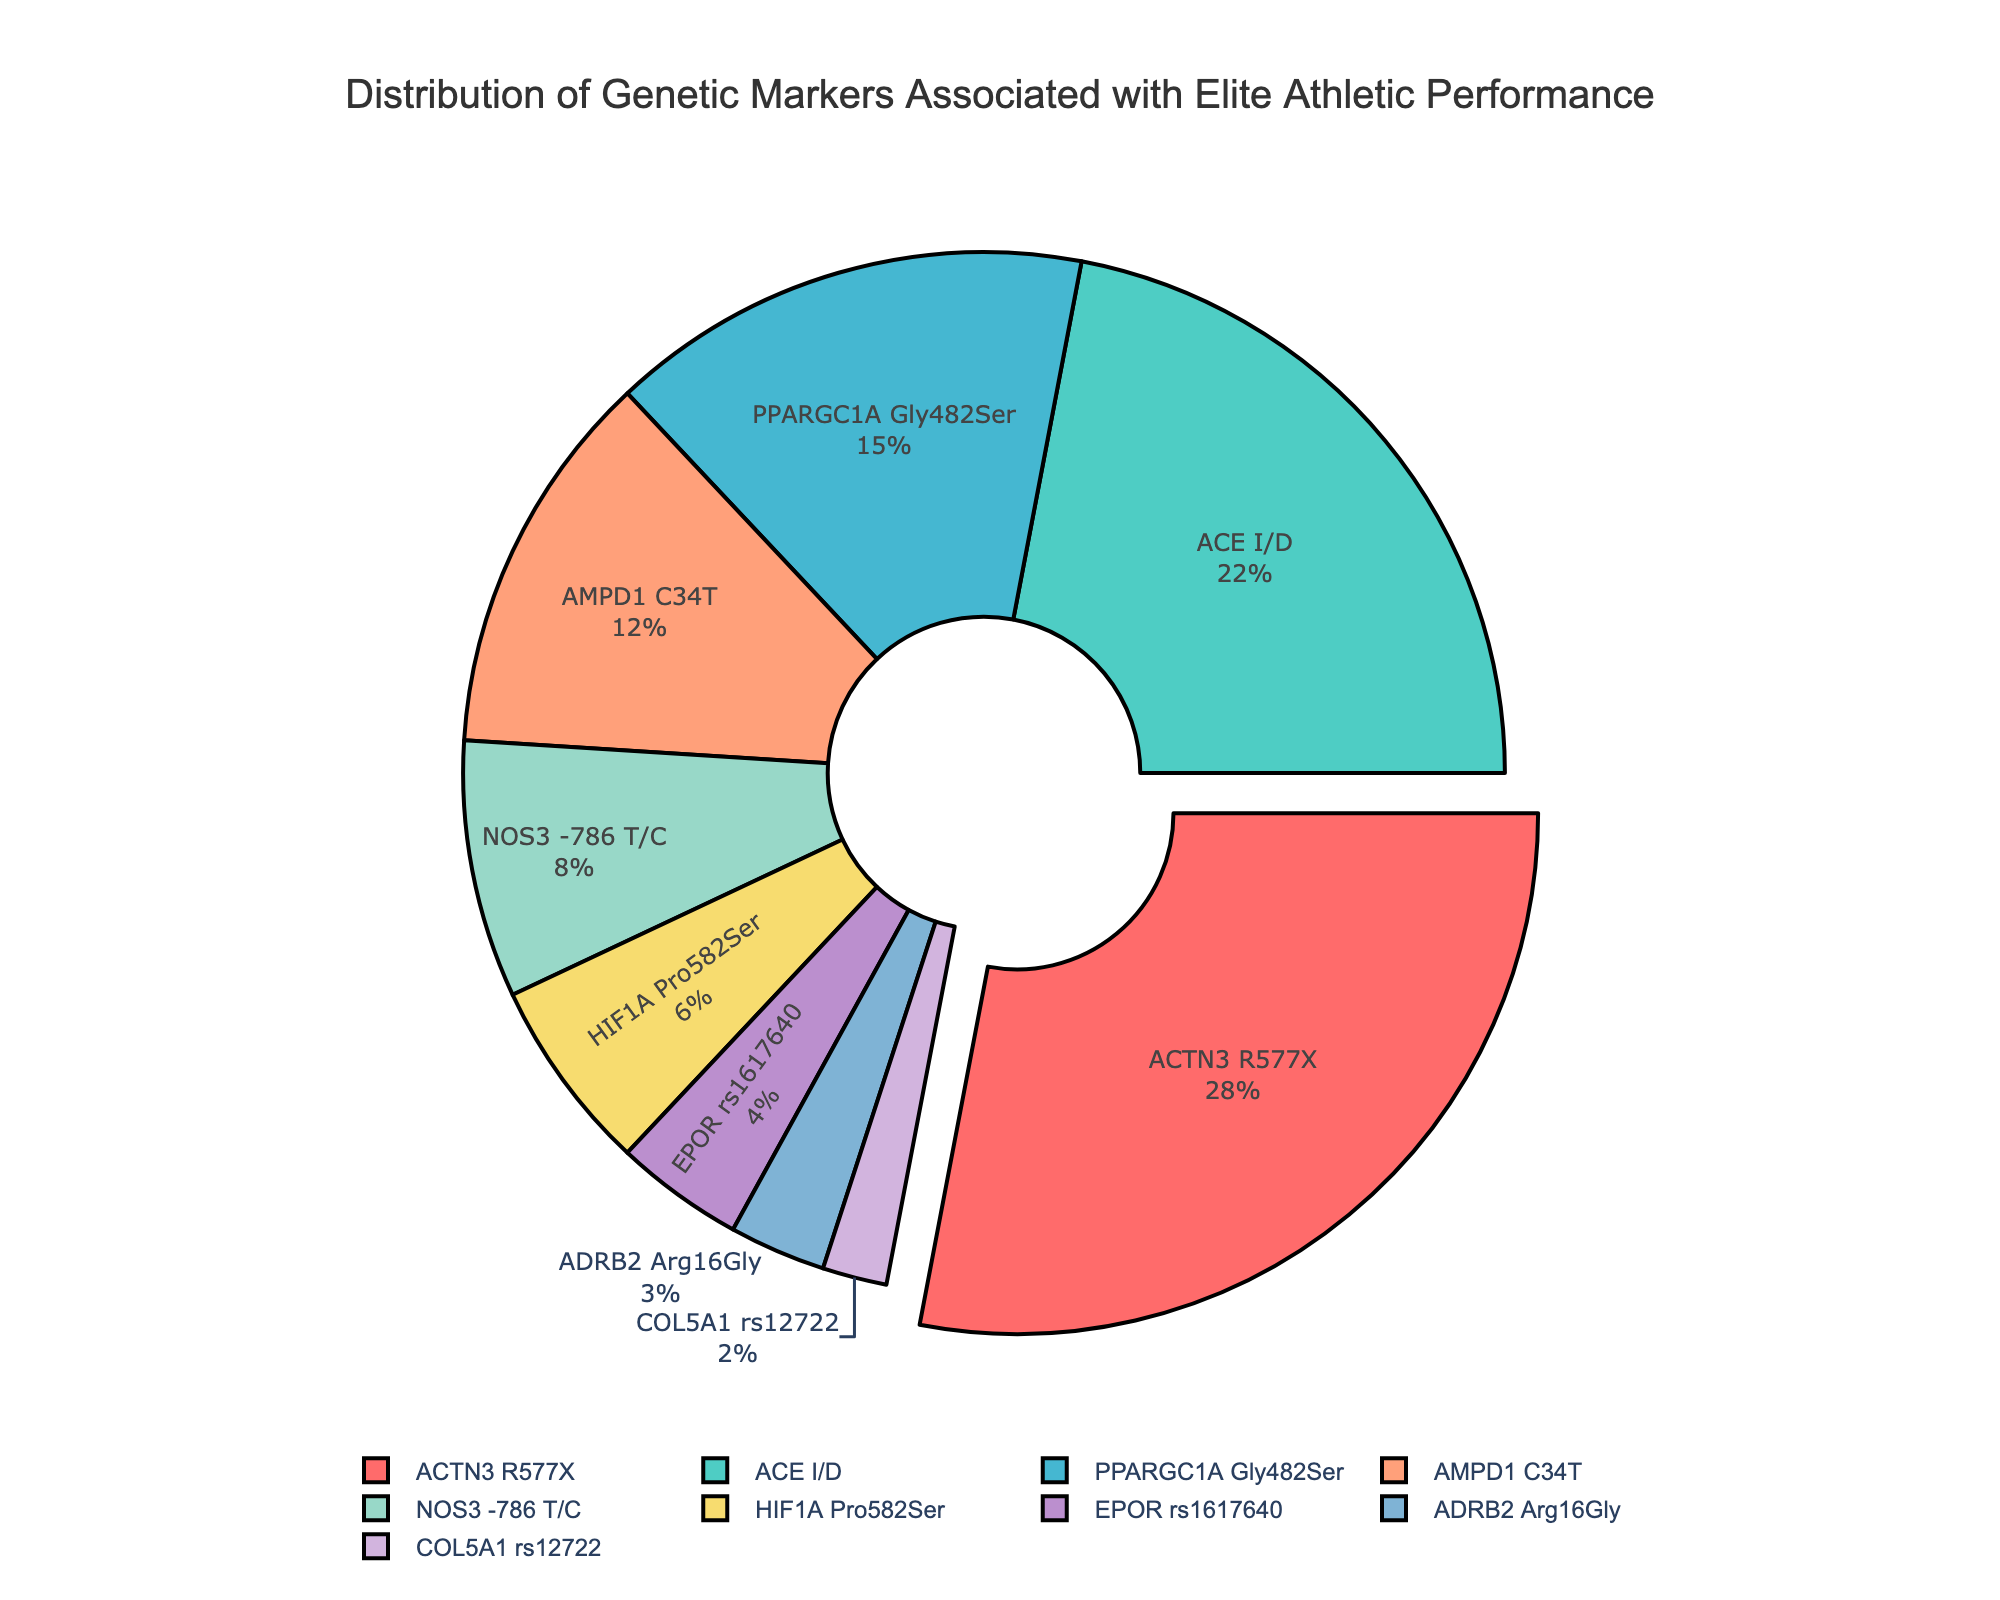What is the percentage of ACTN3 R577X genetic marker? The ACTN3 R577X genetic marker is labeled on the pie chart with a percentage value next to its label.
Answer: 28% Which genetic marker has the lowest percentage? The pie chart sections with the smallest area represent the lowest percentages, which corresponds to the COL5A1 rs12722.
Answer: COL5A1 rs12722 Which genetic markers have a percentage of over 20%? Identify the sections in the pie chart that have percentage values greater than 20%. These sections correspond to the genetic markers ACTN3 R577X and ACE I/D.
Answer: ACTN3 R577X and ACE I/D How much larger is the ACTN3 R577X percentage compared to the ADRB2 Arg16Gly percentage? Subtract the percentage of ADRB2 Arg16Gly from the percentage of ACTN3 R577X (28 - 3).
Answer: 25% Which genetic marker section appears red? Locate the section in the pie chart that is visually colored red.
Answer: ACTN3 R577X What is the combined percentage of the two genetic markers with the smallest percentages? Add the percentage values of the smallest two sections: COL5A1 rs12722 (2%) and ADRB2 Arg16Gly (3%) (2 + 3).
Answer: 5% What is the total percentage of genetic markers less than 10%? Sum the percentages of the sections that represent less than 10%: NOS3 -786 T/C (8%), HIF1A Pro582Ser (6%), EPOR rs1617640 (4%), ADRB2 Arg16Gly (3%), and COL5A1 rs12722 (2%) (8 + 6 + 4 + 3 + 2).
Answer: 23% Which section is pulled out from the pie chart and why? Identify the section that appears separated or pulled out from the chart, indicating it has the highest percentage. That section is ACTN3 R577X.
Answer: ACTN3 R577X What is the approximate color of the ACE I/D section? Examine the visual color data and identify the color associated with ACE I/D section of the pie chart.
Answer: Greenish-blue Among ACTN3 R577X and PPARGC1A Gly482Ser, which genetic marker has a higher percentage? Compare the percentages labeled for ACTN3 R577X (28%) and PPARGC1A Gly482Ser (15%).
Answer: ACTN3 R577X 